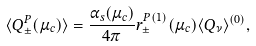<formula> <loc_0><loc_0><loc_500><loc_500>\langle Q _ { \pm } ^ { P } ( \mu _ { c } ) \rangle = \frac { \alpha _ { s } ( \mu _ { c } ) } { 4 \pi } r _ { \pm } ^ { P ( 1 ) } ( \mu _ { c } ) \langle Q _ { \nu } \rangle ^ { ( 0 ) } ,</formula> 